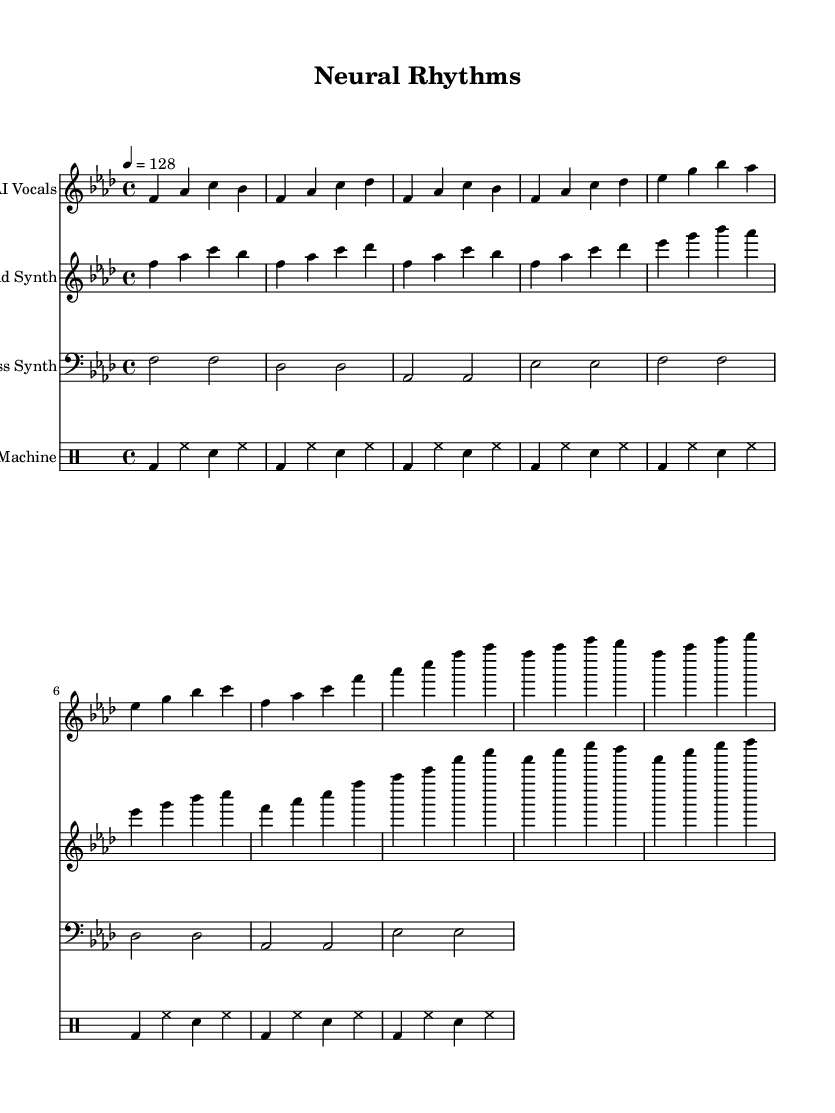What is the key signature of this music? The key signature is indicated at the beginning of the score, which shows the note F with four flats. This corresponds to the key of F minor.
Answer: F minor What is the time signature of this music? The time signature is shown as 4/4 at the beginning of the score. This indicates that there are four beats in each measure and a quarter note receives one beat.
Answer: 4/4 What is the tempo of this music? The tempo is specified in the score as 4 = 128. This means that there are 128 beats per minute, providing a lively pace for the performance.
Answer: 128 How many measures are in the AI Vocals section? To determine the number of measures, we can count the instances of bar lines in the AI Vocals part. Each pair of bar lines indicates the end of a measure. There are eight measures in total for the AI Vocals section.
Answer: 8 Which part has the highest pitch? By examining the relative positioning of the musical notes on the staff, we can assess the pitch. The AI Vocals and Lead Synth sections have higher notes than the Bass Synth and Drum Machine. In this score, the Lead Synth contains the highest pitches among the parts.
Answer: Lead Synth What type of instruments are used in this piece? The score includes vocals generated by AI, a lead synthesizer, a bass synthesizer, and a drum machine. These reflect typical instruments used in experimental dance music.
Answer: Vocal synth, lead synth, bass synth, drum machine Which section features a repetitive rhythmic pattern? By analyzing the measures across the sections, we notice that the Drum Machine part exhibits a repetitive pattern with consistent use of kick and hi-hat sounds, contributing to the dance rhythm characteristic of the genre.
Answer: Drum Machine 